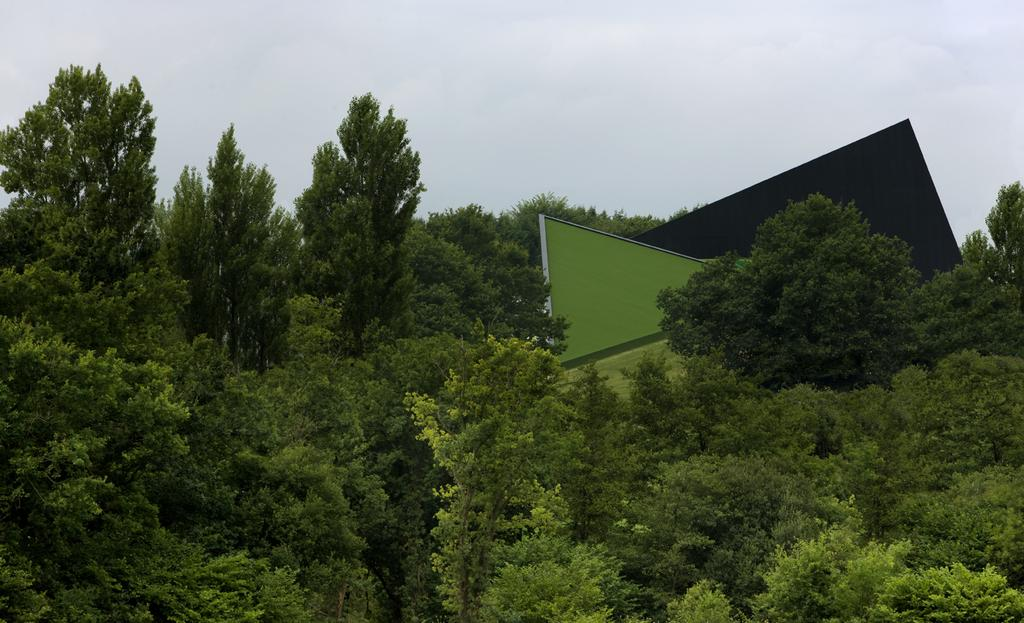What type of vegetation can be seen in the image? There are trees in the image. What else is present in the image besides the trees? There are other objects in the image. What is visible in the background of the image? The sky is visible in the background of the image. How many eyes can be seen on the trees in the image? Trees do not have eyes, so there are no eyes visible on the trees in the image. Is there a knot visible in the image? There is no mention of a knot in the provided facts, so it cannot be determined if a knot is present in the image. 